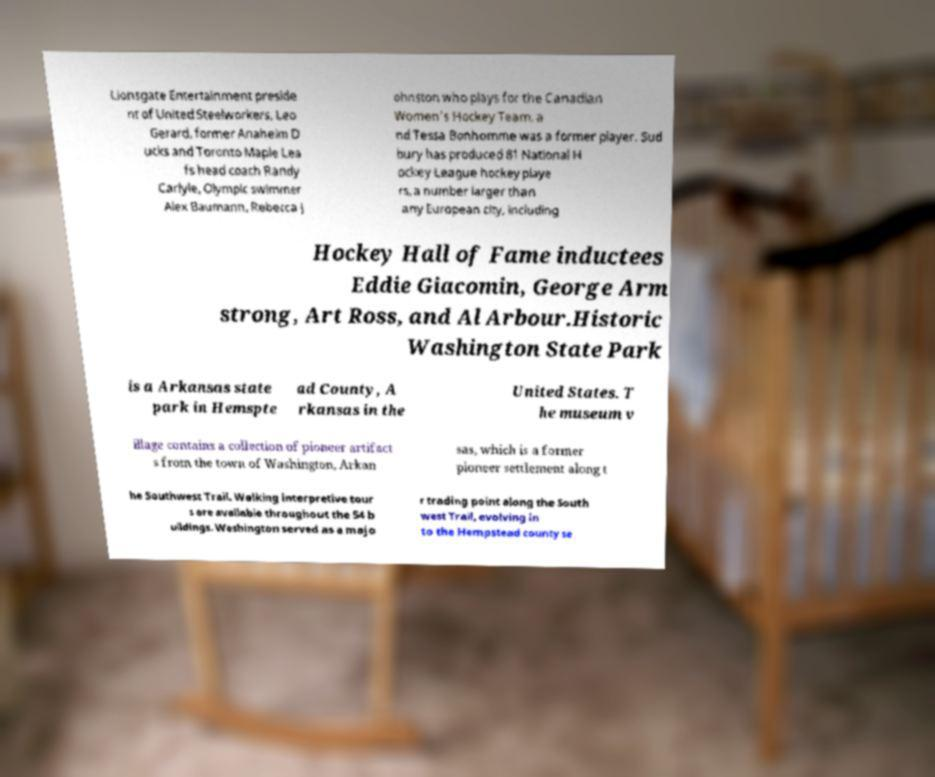Could you extract and type out the text from this image? Lionsgate Entertainment preside nt of United Steelworkers, Leo Gerard, former Anaheim D ucks and Toronto Maple Lea fs head coach Randy Carlyle, Olympic swimmer Alex Baumann, Rebecca J ohnston who plays for the Canadian Women's Hockey Team, a nd Tessa Bonhomme was a former player. Sud bury has produced 81 National H ockey League hockey playe rs, a number larger than any European city, including Hockey Hall of Fame inductees Eddie Giacomin, George Arm strong, Art Ross, and Al Arbour.Historic Washington State Park is a Arkansas state park in Hemspte ad County, A rkansas in the United States. T he museum v illage contains a collection of pioneer artifact s from the town of Washington, Arkan sas, which is a former pioneer settlement along t he Southwest Trail. Walking interpretive tour s are available throughout the 54 b uildings. Washington served as a majo r trading point along the South west Trail, evolving in to the Hempstead county se 